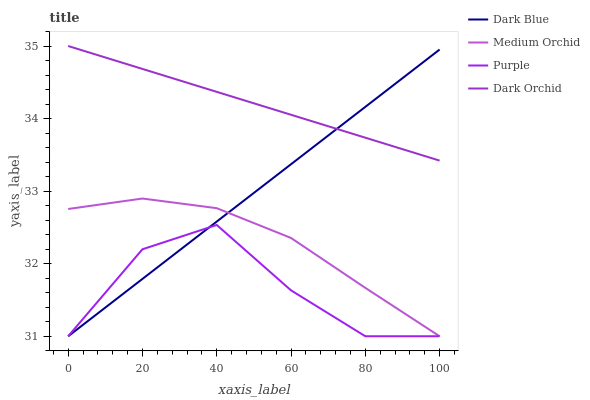Does Purple have the minimum area under the curve?
Answer yes or no. Yes. Does Dark Orchid have the maximum area under the curve?
Answer yes or no. Yes. Does Dark Blue have the minimum area under the curve?
Answer yes or no. No. Does Dark Blue have the maximum area under the curve?
Answer yes or no. No. Is Dark Blue the smoothest?
Answer yes or no. Yes. Is Purple the roughest?
Answer yes or no. Yes. Is Medium Orchid the smoothest?
Answer yes or no. No. Is Medium Orchid the roughest?
Answer yes or no. No. Does Purple have the lowest value?
Answer yes or no. Yes. Does Dark Orchid have the lowest value?
Answer yes or no. No. Does Dark Orchid have the highest value?
Answer yes or no. Yes. Does Dark Blue have the highest value?
Answer yes or no. No. Is Purple less than Dark Orchid?
Answer yes or no. Yes. Is Dark Orchid greater than Purple?
Answer yes or no. Yes. Does Medium Orchid intersect Dark Blue?
Answer yes or no. Yes. Is Medium Orchid less than Dark Blue?
Answer yes or no. No. Is Medium Orchid greater than Dark Blue?
Answer yes or no. No. Does Purple intersect Dark Orchid?
Answer yes or no. No. 